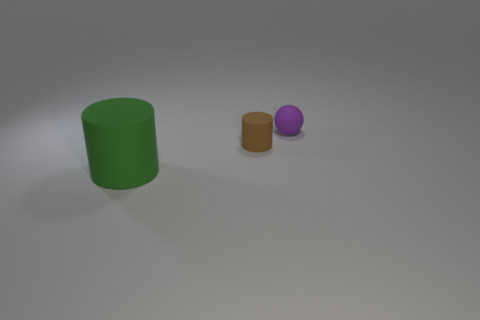Add 2 cyan rubber cubes. How many objects exist? 5 Subtract all green cylinders. How many cylinders are left? 1 Subtract all cylinders. How many objects are left? 1 Subtract 1 cylinders. How many cylinders are left? 1 Subtract all purple cubes. How many green balls are left? 0 Subtract all purple matte balls. Subtract all cylinders. How many objects are left? 0 Add 2 cylinders. How many cylinders are left? 4 Add 2 large gray matte balls. How many large gray matte balls exist? 2 Subtract 0 gray blocks. How many objects are left? 3 Subtract all blue balls. Subtract all purple cylinders. How many balls are left? 1 